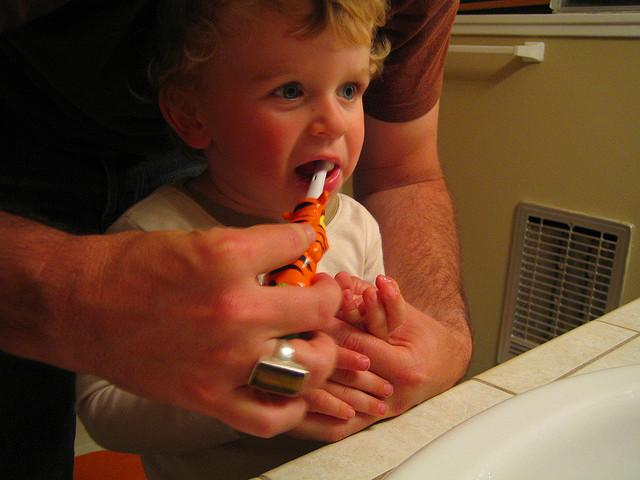What type of animal is the cartoon figure portrayed here based?

Choices:
A) tiger
B) pigeon
C) dog
D) owl tiger 